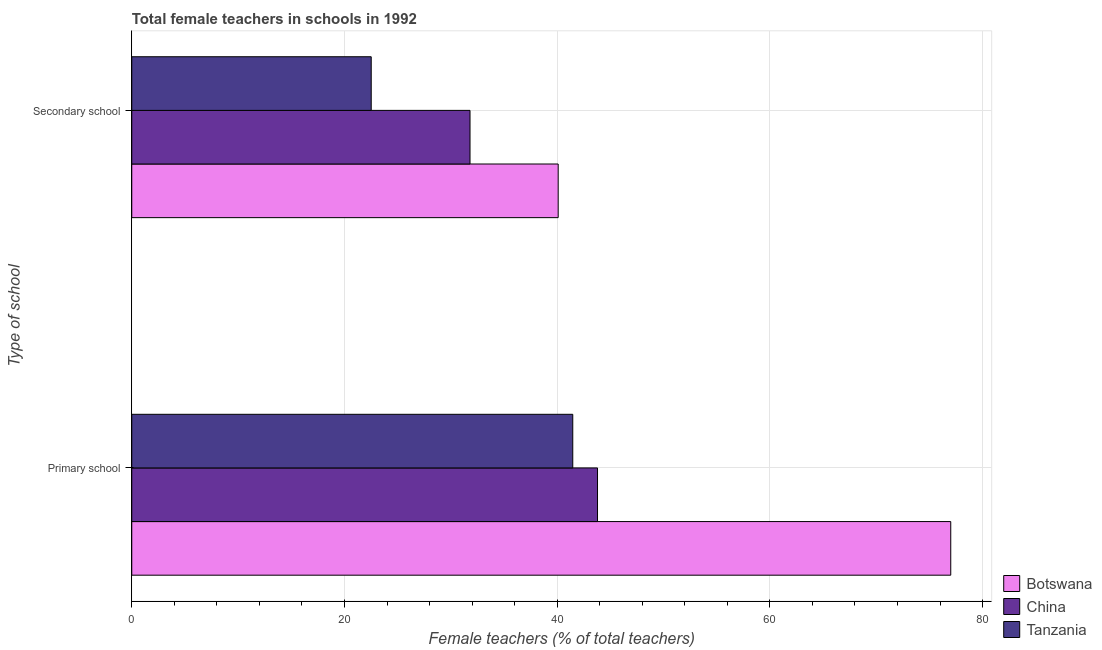How many different coloured bars are there?
Keep it short and to the point. 3. How many groups of bars are there?
Your answer should be compact. 2. Are the number of bars per tick equal to the number of legend labels?
Make the answer very short. Yes. Are the number of bars on each tick of the Y-axis equal?
Provide a succinct answer. Yes. How many bars are there on the 1st tick from the top?
Your response must be concise. 3. How many bars are there on the 1st tick from the bottom?
Your response must be concise. 3. What is the label of the 2nd group of bars from the top?
Your answer should be very brief. Primary school. What is the percentage of female teachers in primary schools in China?
Give a very brief answer. 43.79. Across all countries, what is the maximum percentage of female teachers in primary schools?
Ensure brevity in your answer.  77. Across all countries, what is the minimum percentage of female teachers in primary schools?
Ensure brevity in your answer.  41.47. In which country was the percentage of female teachers in secondary schools maximum?
Offer a terse response. Botswana. In which country was the percentage of female teachers in primary schools minimum?
Provide a short and direct response. Tanzania. What is the total percentage of female teachers in primary schools in the graph?
Give a very brief answer. 162.26. What is the difference between the percentage of female teachers in primary schools in China and that in Botswana?
Keep it short and to the point. -33.21. What is the difference between the percentage of female teachers in primary schools in Botswana and the percentage of female teachers in secondary schools in Tanzania?
Your answer should be very brief. 54.49. What is the average percentage of female teachers in primary schools per country?
Offer a very short reply. 54.09. What is the difference between the percentage of female teachers in secondary schools and percentage of female teachers in primary schools in Botswana?
Ensure brevity in your answer.  -36.91. What is the ratio of the percentage of female teachers in secondary schools in Botswana to that in China?
Provide a succinct answer. 1.26. Is the percentage of female teachers in primary schools in Tanzania less than that in China?
Your response must be concise. Yes. In how many countries, is the percentage of female teachers in secondary schools greater than the average percentage of female teachers in secondary schools taken over all countries?
Ensure brevity in your answer.  2. What does the 1st bar from the top in Secondary school represents?
Give a very brief answer. Tanzania. What does the 1st bar from the bottom in Secondary school represents?
Offer a terse response. Botswana. Are all the bars in the graph horizontal?
Provide a succinct answer. Yes. Does the graph contain grids?
Offer a very short reply. Yes. Where does the legend appear in the graph?
Your answer should be very brief. Bottom right. How many legend labels are there?
Your answer should be compact. 3. What is the title of the graph?
Your answer should be compact. Total female teachers in schools in 1992. Does "Burkina Faso" appear as one of the legend labels in the graph?
Your response must be concise. No. What is the label or title of the X-axis?
Your answer should be very brief. Female teachers (% of total teachers). What is the label or title of the Y-axis?
Your response must be concise. Type of school. What is the Female teachers (% of total teachers) in Botswana in Primary school?
Provide a short and direct response. 77. What is the Female teachers (% of total teachers) in China in Primary school?
Make the answer very short. 43.79. What is the Female teachers (% of total teachers) in Tanzania in Primary school?
Make the answer very short. 41.47. What is the Female teachers (% of total teachers) of Botswana in Secondary school?
Ensure brevity in your answer.  40.09. What is the Female teachers (% of total teachers) in China in Secondary school?
Provide a short and direct response. 31.8. What is the Female teachers (% of total teachers) in Tanzania in Secondary school?
Your answer should be compact. 22.51. Across all Type of school, what is the maximum Female teachers (% of total teachers) in Botswana?
Ensure brevity in your answer.  77. Across all Type of school, what is the maximum Female teachers (% of total teachers) of China?
Offer a terse response. 43.79. Across all Type of school, what is the maximum Female teachers (% of total teachers) of Tanzania?
Offer a terse response. 41.47. Across all Type of school, what is the minimum Female teachers (% of total teachers) of Botswana?
Offer a very short reply. 40.09. Across all Type of school, what is the minimum Female teachers (% of total teachers) of China?
Give a very brief answer. 31.8. Across all Type of school, what is the minimum Female teachers (% of total teachers) in Tanzania?
Your answer should be very brief. 22.51. What is the total Female teachers (% of total teachers) of Botswana in the graph?
Provide a short and direct response. 117.1. What is the total Female teachers (% of total teachers) in China in the graph?
Keep it short and to the point. 75.6. What is the total Female teachers (% of total teachers) in Tanzania in the graph?
Your response must be concise. 63.98. What is the difference between the Female teachers (% of total teachers) in Botswana in Primary school and that in Secondary school?
Make the answer very short. 36.91. What is the difference between the Female teachers (% of total teachers) of China in Primary school and that in Secondary school?
Your answer should be very brief. 11.99. What is the difference between the Female teachers (% of total teachers) in Tanzania in Primary school and that in Secondary school?
Keep it short and to the point. 18.95. What is the difference between the Female teachers (% of total teachers) of Botswana in Primary school and the Female teachers (% of total teachers) of China in Secondary school?
Provide a succinct answer. 45.2. What is the difference between the Female teachers (% of total teachers) in Botswana in Primary school and the Female teachers (% of total teachers) in Tanzania in Secondary school?
Your answer should be very brief. 54.49. What is the difference between the Female teachers (% of total teachers) of China in Primary school and the Female teachers (% of total teachers) of Tanzania in Secondary school?
Your answer should be very brief. 21.28. What is the average Female teachers (% of total teachers) in Botswana per Type of school?
Your answer should be very brief. 58.55. What is the average Female teachers (% of total teachers) in China per Type of school?
Make the answer very short. 37.8. What is the average Female teachers (% of total teachers) in Tanzania per Type of school?
Your answer should be very brief. 31.99. What is the difference between the Female teachers (% of total teachers) of Botswana and Female teachers (% of total teachers) of China in Primary school?
Your answer should be compact. 33.21. What is the difference between the Female teachers (% of total teachers) of Botswana and Female teachers (% of total teachers) of Tanzania in Primary school?
Keep it short and to the point. 35.54. What is the difference between the Female teachers (% of total teachers) in China and Female teachers (% of total teachers) in Tanzania in Primary school?
Your answer should be compact. 2.33. What is the difference between the Female teachers (% of total teachers) of Botswana and Female teachers (% of total teachers) of China in Secondary school?
Make the answer very short. 8.29. What is the difference between the Female teachers (% of total teachers) in Botswana and Female teachers (% of total teachers) in Tanzania in Secondary school?
Offer a terse response. 17.58. What is the difference between the Female teachers (% of total teachers) in China and Female teachers (% of total teachers) in Tanzania in Secondary school?
Offer a terse response. 9.29. What is the ratio of the Female teachers (% of total teachers) in Botswana in Primary school to that in Secondary school?
Give a very brief answer. 1.92. What is the ratio of the Female teachers (% of total teachers) of China in Primary school to that in Secondary school?
Keep it short and to the point. 1.38. What is the ratio of the Female teachers (% of total teachers) in Tanzania in Primary school to that in Secondary school?
Provide a succinct answer. 1.84. What is the difference between the highest and the second highest Female teachers (% of total teachers) of Botswana?
Provide a short and direct response. 36.91. What is the difference between the highest and the second highest Female teachers (% of total teachers) in China?
Make the answer very short. 11.99. What is the difference between the highest and the second highest Female teachers (% of total teachers) in Tanzania?
Make the answer very short. 18.95. What is the difference between the highest and the lowest Female teachers (% of total teachers) of Botswana?
Your response must be concise. 36.91. What is the difference between the highest and the lowest Female teachers (% of total teachers) of China?
Give a very brief answer. 11.99. What is the difference between the highest and the lowest Female teachers (% of total teachers) in Tanzania?
Your response must be concise. 18.95. 